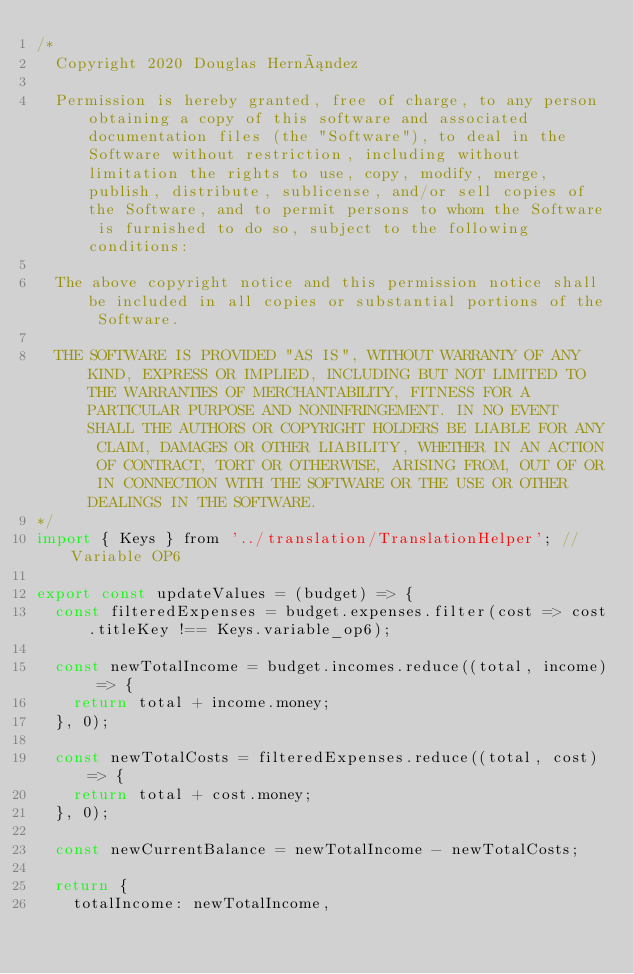<code> <loc_0><loc_0><loc_500><loc_500><_JavaScript_>/*
	Copyright 2020 Douglas Hernández

	Permission is hereby granted, free of charge, to any person obtaining a copy of this software and associated documentation files (the "Software"), to deal in the Software without restriction, including without limitation the rights to use, copy, modify, merge, publish, distribute, sublicense, and/or sell copies of the Software, and to permit persons to whom the Software is furnished to do so, subject to the following conditions:

	The above copyright notice and this permission notice shall be included in all copies or substantial portions of the Software.

	THE SOFTWARE IS PROVIDED "AS IS", WITHOUT WARRANTY OF ANY KIND, EXPRESS OR IMPLIED, INCLUDING BUT NOT LIMITED TO THE WARRANTIES OF MERCHANTABILITY, FITNESS FOR A PARTICULAR PURPOSE AND NONINFRINGEMENT. IN NO EVENT SHALL THE AUTHORS OR COPYRIGHT HOLDERS BE LIABLE FOR ANY CLAIM, DAMAGES OR OTHER LIABILITY, WHETHER IN AN ACTION OF CONTRACT, TORT OR OTHERWISE, ARISING FROM, OUT OF OR IN CONNECTION WITH THE SOFTWARE OR THE USE OR OTHER DEALINGS IN THE SOFTWARE.
*/
import { Keys } from '../translation/TranslationHelper'; //Variable OP6

export const updateValues = (budget) => {
	const filteredExpenses = budget.expenses.filter(cost => cost.titleKey !== Keys.variable_op6);

	const newTotalIncome = budget.incomes.reduce((total, income) => {
		return total + income.money;
	}, 0);

	const newTotalCosts = filteredExpenses.reduce((total, cost) => {
		return total + cost.money;
	}, 0);

	const newCurrentBalance = newTotalIncome - newTotalCosts;

	return {
		totalIncome: newTotalIncome,</code> 